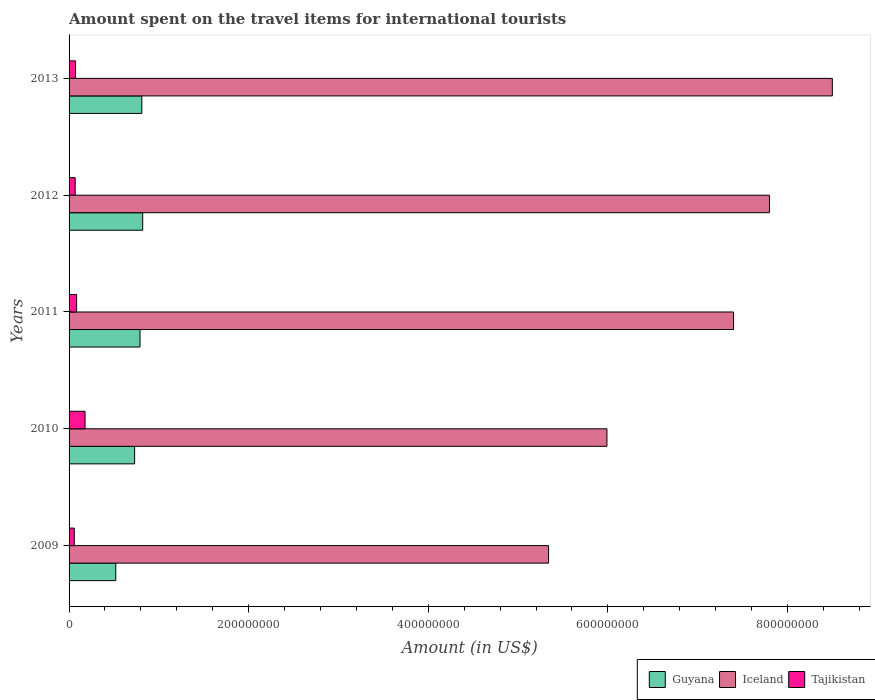How many different coloured bars are there?
Your answer should be very brief. 3. Are the number of bars on each tick of the Y-axis equal?
Your response must be concise. Yes. How many bars are there on the 5th tick from the top?
Give a very brief answer. 3. How many bars are there on the 3rd tick from the bottom?
Offer a terse response. 3. What is the label of the 4th group of bars from the top?
Your response must be concise. 2010. In how many cases, is the number of bars for a given year not equal to the number of legend labels?
Offer a terse response. 0. What is the amount spent on the travel items for international tourists in Tajikistan in 2013?
Ensure brevity in your answer.  7.20e+06. Across all years, what is the maximum amount spent on the travel items for international tourists in Guyana?
Your answer should be very brief. 8.20e+07. Across all years, what is the minimum amount spent on the travel items for international tourists in Tajikistan?
Keep it short and to the point. 5.80e+06. In which year was the amount spent on the travel items for international tourists in Iceland maximum?
Your response must be concise. 2013. In which year was the amount spent on the travel items for international tourists in Tajikistan minimum?
Make the answer very short. 2009. What is the total amount spent on the travel items for international tourists in Guyana in the graph?
Give a very brief answer. 3.67e+08. What is the difference between the amount spent on the travel items for international tourists in Guyana in 2009 and that in 2013?
Ensure brevity in your answer.  -2.90e+07. What is the difference between the amount spent on the travel items for international tourists in Iceland in 2009 and the amount spent on the travel items for international tourists in Tajikistan in 2011?
Offer a very short reply. 5.26e+08. What is the average amount spent on the travel items for international tourists in Tajikistan per year?
Your response must be concise. 9.20e+06. In the year 2011, what is the difference between the amount spent on the travel items for international tourists in Tajikistan and amount spent on the travel items for international tourists in Guyana?
Your answer should be compact. -7.06e+07. What is the ratio of the amount spent on the travel items for international tourists in Tajikistan in 2011 to that in 2012?
Your answer should be compact. 1.24. Is the difference between the amount spent on the travel items for international tourists in Tajikistan in 2010 and 2012 greater than the difference between the amount spent on the travel items for international tourists in Guyana in 2010 and 2012?
Your response must be concise. Yes. What is the difference between the highest and the second highest amount spent on the travel items for international tourists in Iceland?
Give a very brief answer. 7.00e+07. What is the difference between the highest and the lowest amount spent on the travel items for international tourists in Tajikistan?
Ensure brevity in your answer.  1.20e+07. Is the sum of the amount spent on the travel items for international tourists in Tajikistan in 2009 and 2011 greater than the maximum amount spent on the travel items for international tourists in Iceland across all years?
Keep it short and to the point. No. What does the 2nd bar from the top in 2012 represents?
Make the answer very short. Iceland. What does the 1st bar from the bottom in 2010 represents?
Offer a terse response. Guyana. What is the difference between two consecutive major ticks on the X-axis?
Keep it short and to the point. 2.00e+08. Does the graph contain grids?
Offer a terse response. No. How are the legend labels stacked?
Keep it short and to the point. Horizontal. What is the title of the graph?
Keep it short and to the point. Amount spent on the travel items for international tourists. What is the label or title of the X-axis?
Your response must be concise. Amount (in US$). What is the label or title of the Y-axis?
Provide a short and direct response. Years. What is the Amount (in US$) in Guyana in 2009?
Offer a very short reply. 5.20e+07. What is the Amount (in US$) in Iceland in 2009?
Your answer should be very brief. 5.34e+08. What is the Amount (in US$) in Tajikistan in 2009?
Make the answer very short. 5.80e+06. What is the Amount (in US$) of Guyana in 2010?
Your answer should be very brief. 7.30e+07. What is the Amount (in US$) in Iceland in 2010?
Keep it short and to the point. 5.99e+08. What is the Amount (in US$) of Tajikistan in 2010?
Offer a terse response. 1.78e+07. What is the Amount (in US$) of Guyana in 2011?
Your response must be concise. 7.90e+07. What is the Amount (in US$) of Iceland in 2011?
Provide a short and direct response. 7.40e+08. What is the Amount (in US$) in Tajikistan in 2011?
Keep it short and to the point. 8.40e+06. What is the Amount (in US$) of Guyana in 2012?
Make the answer very short. 8.20e+07. What is the Amount (in US$) of Iceland in 2012?
Offer a very short reply. 7.80e+08. What is the Amount (in US$) of Tajikistan in 2012?
Give a very brief answer. 6.80e+06. What is the Amount (in US$) in Guyana in 2013?
Your answer should be compact. 8.10e+07. What is the Amount (in US$) in Iceland in 2013?
Offer a terse response. 8.50e+08. What is the Amount (in US$) in Tajikistan in 2013?
Your response must be concise. 7.20e+06. Across all years, what is the maximum Amount (in US$) of Guyana?
Your answer should be very brief. 8.20e+07. Across all years, what is the maximum Amount (in US$) of Iceland?
Ensure brevity in your answer.  8.50e+08. Across all years, what is the maximum Amount (in US$) of Tajikistan?
Provide a succinct answer. 1.78e+07. Across all years, what is the minimum Amount (in US$) in Guyana?
Make the answer very short. 5.20e+07. Across all years, what is the minimum Amount (in US$) of Iceland?
Offer a terse response. 5.34e+08. Across all years, what is the minimum Amount (in US$) of Tajikistan?
Provide a succinct answer. 5.80e+06. What is the total Amount (in US$) in Guyana in the graph?
Make the answer very short. 3.67e+08. What is the total Amount (in US$) in Iceland in the graph?
Offer a terse response. 3.50e+09. What is the total Amount (in US$) in Tajikistan in the graph?
Your response must be concise. 4.60e+07. What is the difference between the Amount (in US$) in Guyana in 2009 and that in 2010?
Provide a short and direct response. -2.10e+07. What is the difference between the Amount (in US$) of Iceland in 2009 and that in 2010?
Your answer should be compact. -6.50e+07. What is the difference between the Amount (in US$) in Tajikistan in 2009 and that in 2010?
Make the answer very short. -1.20e+07. What is the difference between the Amount (in US$) of Guyana in 2009 and that in 2011?
Offer a very short reply. -2.70e+07. What is the difference between the Amount (in US$) in Iceland in 2009 and that in 2011?
Keep it short and to the point. -2.06e+08. What is the difference between the Amount (in US$) in Tajikistan in 2009 and that in 2011?
Ensure brevity in your answer.  -2.60e+06. What is the difference between the Amount (in US$) in Guyana in 2009 and that in 2012?
Make the answer very short. -3.00e+07. What is the difference between the Amount (in US$) of Iceland in 2009 and that in 2012?
Your response must be concise. -2.46e+08. What is the difference between the Amount (in US$) in Tajikistan in 2009 and that in 2012?
Provide a short and direct response. -1.00e+06. What is the difference between the Amount (in US$) in Guyana in 2009 and that in 2013?
Provide a succinct answer. -2.90e+07. What is the difference between the Amount (in US$) in Iceland in 2009 and that in 2013?
Offer a very short reply. -3.16e+08. What is the difference between the Amount (in US$) in Tajikistan in 2009 and that in 2013?
Give a very brief answer. -1.40e+06. What is the difference between the Amount (in US$) of Guyana in 2010 and that in 2011?
Keep it short and to the point. -6.00e+06. What is the difference between the Amount (in US$) of Iceland in 2010 and that in 2011?
Offer a terse response. -1.41e+08. What is the difference between the Amount (in US$) of Tajikistan in 2010 and that in 2011?
Your answer should be compact. 9.40e+06. What is the difference between the Amount (in US$) in Guyana in 2010 and that in 2012?
Make the answer very short. -9.00e+06. What is the difference between the Amount (in US$) of Iceland in 2010 and that in 2012?
Offer a very short reply. -1.81e+08. What is the difference between the Amount (in US$) in Tajikistan in 2010 and that in 2012?
Provide a short and direct response. 1.10e+07. What is the difference between the Amount (in US$) of Guyana in 2010 and that in 2013?
Ensure brevity in your answer.  -8.00e+06. What is the difference between the Amount (in US$) of Iceland in 2010 and that in 2013?
Your answer should be compact. -2.51e+08. What is the difference between the Amount (in US$) in Tajikistan in 2010 and that in 2013?
Give a very brief answer. 1.06e+07. What is the difference between the Amount (in US$) in Guyana in 2011 and that in 2012?
Your answer should be very brief. -3.00e+06. What is the difference between the Amount (in US$) of Iceland in 2011 and that in 2012?
Ensure brevity in your answer.  -4.00e+07. What is the difference between the Amount (in US$) of Tajikistan in 2011 and that in 2012?
Ensure brevity in your answer.  1.60e+06. What is the difference between the Amount (in US$) in Guyana in 2011 and that in 2013?
Your answer should be compact. -2.00e+06. What is the difference between the Amount (in US$) in Iceland in 2011 and that in 2013?
Keep it short and to the point. -1.10e+08. What is the difference between the Amount (in US$) in Tajikistan in 2011 and that in 2013?
Make the answer very short. 1.20e+06. What is the difference between the Amount (in US$) of Iceland in 2012 and that in 2013?
Keep it short and to the point. -7.00e+07. What is the difference between the Amount (in US$) in Tajikistan in 2012 and that in 2013?
Offer a very short reply. -4.00e+05. What is the difference between the Amount (in US$) of Guyana in 2009 and the Amount (in US$) of Iceland in 2010?
Your answer should be very brief. -5.47e+08. What is the difference between the Amount (in US$) of Guyana in 2009 and the Amount (in US$) of Tajikistan in 2010?
Offer a very short reply. 3.42e+07. What is the difference between the Amount (in US$) of Iceland in 2009 and the Amount (in US$) of Tajikistan in 2010?
Ensure brevity in your answer.  5.16e+08. What is the difference between the Amount (in US$) of Guyana in 2009 and the Amount (in US$) of Iceland in 2011?
Make the answer very short. -6.88e+08. What is the difference between the Amount (in US$) in Guyana in 2009 and the Amount (in US$) in Tajikistan in 2011?
Offer a very short reply. 4.36e+07. What is the difference between the Amount (in US$) in Iceland in 2009 and the Amount (in US$) in Tajikistan in 2011?
Offer a very short reply. 5.26e+08. What is the difference between the Amount (in US$) in Guyana in 2009 and the Amount (in US$) in Iceland in 2012?
Make the answer very short. -7.28e+08. What is the difference between the Amount (in US$) of Guyana in 2009 and the Amount (in US$) of Tajikistan in 2012?
Make the answer very short. 4.52e+07. What is the difference between the Amount (in US$) in Iceland in 2009 and the Amount (in US$) in Tajikistan in 2012?
Keep it short and to the point. 5.27e+08. What is the difference between the Amount (in US$) in Guyana in 2009 and the Amount (in US$) in Iceland in 2013?
Keep it short and to the point. -7.98e+08. What is the difference between the Amount (in US$) of Guyana in 2009 and the Amount (in US$) of Tajikistan in 2013?
Your answer should be compact. 4.48e+07. What is the difference between the Amount (in US$) of Iceland in 2009 and the Amount (in US$) of Tajikistan in 2013?
Provide a short and direct response. 5.27e+08. What is the difference between the Amount (in US$) in Guyana in 2010 and the Amount (in US$) in Iceland in 2011?
Offer a terse response. -6.67e+08. What is the difference between the Amount (in US$) of Guyana in 2010 and the Amount (in US$) of Tajikistan in 2011?
Provide a succinct answer. 6.46e+07. What is the difference between the Amount (in US$) in Iceland in 2010 and the Amount (in US$) in Tajikistan in 2011?
Your response must be concise. 5.91e+08. What is the difference between the Amount (in US$) in Guyana in 2010 and the Amount (in US$) in Iceland in 2012?
Offer a very short reply. -7.07e+08. What is the difference between the Amount (in US$) in Guyana in 2010 and the Amount (in US$) in Tajikistan in 2012?
Give a very brief answer. 6.62e+07. What is the difference between the Amount (in US$) of Iceland in 2010 and the Amount (in US$) of Tajikistan in 2012?
Your answer should be compact. 5.92e+08. What is the difference between the Amount (in US$) in Guyana in 2010 and the Amount (in US$) in Iceland in 2013?
Your answer should be very brief. -7.77e+08. What is the difference between the Amount (in US$) in Guyana in 2010 and the Amount (in US$) in Tajikistan in 2013?
Make the answer very short. 6.58e+07. What is the difference between the Amount (in US$) of Iceland in 2010 and the Amount (in US$) of Tajikistan in 2013?
Keep it short and to the point. 5.92e+08. What is the difference between the Amount (in US$) of Guyana in 2011 and the Amount (in US$) of Iceland in 2012?
Give a very brief answer. -7.01e+08. What is the difference between the Amount (in US$) of Guyana in 2011 and the Amount (in US$) of Tajikistan in 2012?
Your answer should be compact. 7.22e+07. What is the difference between the Amount (in US$) in Iceland in 2011 and the Amount (in US$) in Tajikistan in 2012?
Your response must be concise. 7.33e+08. What is the difference between the Amount (in US$) in Guyana in 2011 and the Amount (in US$) in Iceland in 2013?
Give a very brief answer. -7.71e+08. What is the difference between the Amount (in US$) of Guyana in 2011 and the Amount (in US$) of Tajikistan in 2013?
Offer a very short reply. 7.18e+07. What is the difference between the Amount (in US$) in Iceland in 2011 and the Amount (in US$) in Tajikistan in 2013?
Offer a very short reply. 7.33e+08. What is the difference between the Amount (in US$) of Guyana in 2012 and the Amount (in US$) of Iceland in 2013?
Your answer should be very brief. -7.68e+08. What is the difference between the Amount (in US$) of Guyana in 2012 and the Amount (in US$) of Tajikistan in 2013?
Offer a very short reply. 7.48e+07. What is the difference between the Amount (in US$) of Iceland in 2012 and the Amount (in US$) of Tajikistan in 2013?
Offer a very short reply. 7.73e+08. What is the average Amount (in US$) in Guyana per year?
Offer a terse response. 7.34e+07. What is the average Amount (in US$) in Iceland per year?
Your answer should be compact. 7.01e+08. What is the average Amount (in US$) in Tajikistan per year?
Provide a short and direct response. 9.20e+06. In the year 2009, what is the difference between the Amount (in US$) in Guyana and Amount (in US$) in Iceland?
Provide a short and direct response. -4.82e+08. In the year 2009, what is the difference between the Amount (in US$) in Guyana and Amount (in US$) in Tajikistan?
Offer a very short reply. 4.62e+07. In the year 2009, what is the difference between the Amount (in US$) of Iceland and Amount (in US$) of Tajikistan?
Your answer should be compact. 5.28e+08. In the year 2010, what is the difference between the Amount (in US$) of Guyana and Amount (in US$) of Iceland?
Provide a succinct answer. -5.26e+08. In the year 2010, what is the difference between the Amount (in US$) in Guyana and Amount (in US$) in Tajikistan?
Provide a short and direct response. 5.52e+07. In the year 2010, what is the difference between the Amount (in US$) of Iceland and Amount (in US$) of Tajikistan?
Provide a succinct answer. 5.81e+08. In the year 2011, what is the difference between the Amount (in US$) in Guyana and Amount (in US$) in Iceland?
Provide a short and direct response. -6.61e+08. In the year 2011, what is the difference between the Amount (in US$) of Guyana and Amount (in US$) of Tajikistan?
Keep it short and to the point. 7.06e+07. In the year 2011, what is the difference between the Amount (in US$) of Iceland and Amount (in US$) of Tajikistan?
Offer a very short reply. 7.32e+08. In the year 2012, what is the difference between the Amount (in US$) of Guyana and Amount (in US$) of Iceland?
Your answer should be compact. -6.98e+08. In the year 2012, what is the difference between the Amount (in US$) in Guyana and Amount (in US$) in Tajikistan?
Keep it short and to the point. 7.52e+07. In the year 2012, what is the difference between the Amount (in US$) of Iceland and Amount (in US$) of Tajikistan?
Provide a short and direct response. 7.73e+08. In the year 2013, what is the difference between the Amount (in US$) in Guyana and Amount (in US$) in Iceland?
Provide a short and direct response. -7.69e+08. In the year 2013, what is the difference between the Amount (in US$) in Guyana and Amount (in US$) in Tajikistan?
Keep it short and to the point. 7.38e+07. In the year 2013, what is the difference between the Amount (in US$) in Iceland and Amount (in US$) in Tajikistan?
Your response must be concise. 8.43e+08. What is the ratio of the Amount (in US$) in Guyana in 2009 to that in 2010?
Provide a succinct answer. 0.71. What is the ratio of the Amount (in US$) in Iceland in 2009 to that in 2010?
Ensure brevity in your answer.  0.89. What is the ratio of the Amount (in US$) in Tajikistan in 2009 to that in 2010?
Make the answer very short. 0.33. What is the ratio of the Amount (in US$) in Guyana in 2009 to that in 2011?
Make the answer very short. 0.66. What is the ratio of the Amount (in US$) in Iceland in 2009 to that in 2011?
Give a very brief answer. 0.72. What is the ratio of the Amount (in US$) in Tajikistan in 2009 to that in 2011?
Your response must be concise. 0.69. What is the ratio of the Amount (in US$) of Guyana in 2009 to that in 2012?
Give a very brief answer. 0.63. What is the ratio of the Amount (in US$) of Iceland in 2009 to that in 2012?
Offer a very short reply. 0.68. What is the ratio of the Amount (in US$) of Tajikistan in 2009 to that in 2012?
Ensure brevity in your answer.  0.85. What is the ratio of the Amount (in US$) of Guyana in 2009 to that in 2013?
Provide a short and direct response. 0.64. What is the ratio of the Amount (in US$) in Iceland in 2009 to that in 2013?
Provide a short and direct response. 0.63. What is the ratio of the Amount (in US$) of Tajikistan in 2009 to that in 2013?
Ensure brevity in your answer.  0.81. What is the ratio of the Amount (in US$) in Guyana in 2010 to that in 2011?
Your answer should be very brief. 0.92. What is the ratio of the Amount (in US$) of Iceland in 2010 to that in 2011?
Your response must be concise. 0.81. What is the ratio of the Amount (in US$) in Tajikistan in 2010 to that in 2011?
Make the answer very short. 2.12. What is the ratio of the Amount (in US$) of Guyana in 2010 to that in 2012?
Provide a succinct answer. 0.89. What is the ratio of the Amount (in US$) in Iceland in 2010 to that in 2012?
Give a very brief answer. 0.77. What is the ratio of the Amount (in US$) in Tajikistan in 2010 to that in 2012?
Offer a very short reply. 2.62. What is the ratio of the Amount (in US$) of Guyana in 2010 to that in 2013?
Make the answer very short. 0.9. What is the ratio of the Amount (in US$) in Iceland in 2010 to that in 2013?
Make the answer very short. 0.7. What is the ratio of the Amount (in US$) of Tajikistan in 2010 to that in 2013?
Ensure brevity in your answer.  2.47. What is the ratio of the Amount (in US$) of Guyana in 2011 to that in 2012?
Give a very brief answer. 0.96. What is the ratio of the Amount (in US$) in Iceland in 2011 to that in 2012?
Offer a very short reply. 0.95. What is the ratio of the Amount (in US$) of Tajikistan in 2011 to that in 2012?
Your response must be concise. 1.24. What is the ratio of the Amount (in US$) of Guyana in 2011 to that in 2013?
Your response must be concise. 0.98. What is the ratio of the Amount (in US$) of Iceland in 2011 to that in 2013?
Give a very brief answer. 0.87. What is the ratio of the Amount (in US$) in Guyana in 2012 to that in 2013?
Offer a terse response. 1.01. What is the ratio of the Amount (in US$) of Iceland in 2012 to that in 2013?
Provide a succinct answer. 0.92. What is the ratio of the Amount (in US$) of Tajikistan in 2012 to that in 2013?
Make the answer very short. 0.94. What is the difference between the highest and the second highest Amount (in US$) of Iceland?
Your answer should be compact. 7.00e+07. What is the difference between the highest and the second highest Amount (in US$) in Tajikistan?
Give a very brief answer. 9.40e+06. What is the difference between the highest and the lowest Amount (in US$) in Guyana?
Your answer should be compact. 3.00e+07. What is the difference between the highest and the lowest Amount (in US$) in Iceland?
Your answer should be compact. 3.16e+08. 